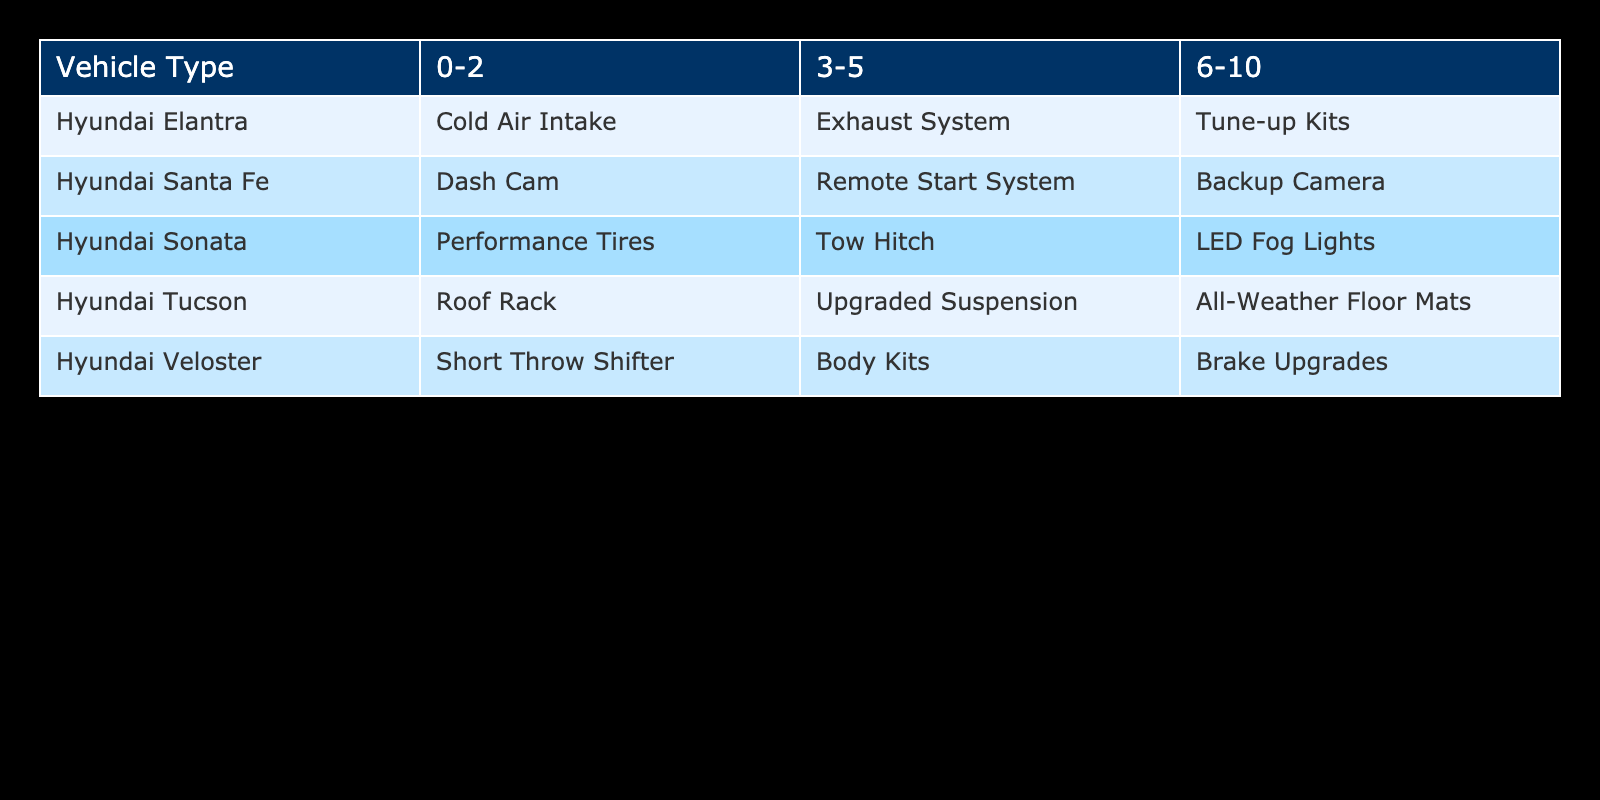What's the popular aftermarket part for a Hyundai Elantra aged 3-5 years? The table shows that for the Hyundai Elantra with a vehicle age of 3-5 years, the popular aftermarket part listed is the Exhaust System.
Answer: Exhaust System Which popular aftermarket part is common for Hyundai vehicles aged 0-2 years? Based on the table, the common aftermarket parts for Hyundai vehicles aged 0-2 years include Cold Air Intake for the Elantra, Performance Tires for the Sonata, Roof Rack for the Tucson, Short Throw Shifter for the Veloster, and Dash Cam for the Santa Fe.
Answer: Various parts Is a Tow Hitch a popular aftermarket part for any Hyundai vehicles aged 6-10 years? Looking at the data, the Tow Hitch is only listed for Hyundai Sonata aged 3-5 years, and there are no listings for 6-10 years, therefore, the answer is no.
Answer: No What popular aftermarket part do Hyundai Tucson owners typically seek for a vehicle age of 3-5 years? The table indicates that the popular aftermarket part for the Hyundai Tucson aged 3-5 years is Upgraded Suspension.
Answer: Upgraded Suspension For vehicles aged 6-10 years, how many different popular aftermarket parts are available across all Hyundai models? The table indicates that for vehicles aged 6-10 years, the available popular aftermarket parts are Tune-up Kits for Elantra, LED Fog Lights for Sonata, All-Weather Floor Mats for Tucson, Brake Upgrades for Veloster, and Backup Camera for Santa Fe, making a total of 5 distinct parts.
Answer: 5 Do all vehicle types have the same popular aftermarket part for 0-2 year old vehicles? Examining the table, each type has different popular aftermarket parts for 0-2 years: Cold Air Intake for Elantra, Performance Tires for Sonata, Roof Rack for Tucson, Short Throw Shifter for Veloster, and Dash Cam for Santa Fe. Therefore, the answer is no.
Answer: No Which aftermarket part is most common for vehicles aged 6-10 years, based on the table? The parts for vehicles aged 6-10 years listed are: Tune-up Kits for Elantra, LED Fog Lights for Sonata, All-Weather Floor Mats for Tucson, Brake Upgrades for Veloster, and Backup Camera for Santa Fe. Since they're all different parts, there is no "most common" part.
Answer: None What is the average number of unique popular aftermarket parts listed for Hyundai vehicles across all age groups? There are 5 unique aftermarket parts for 0-2 years, 4 for 3-5 years, and 5 for 6-10 years. The average can be calculated as (5+4+5)/3 = 14/3 = 4.67, rounding down gives us about 4 unique parts.
Answer: About 4 